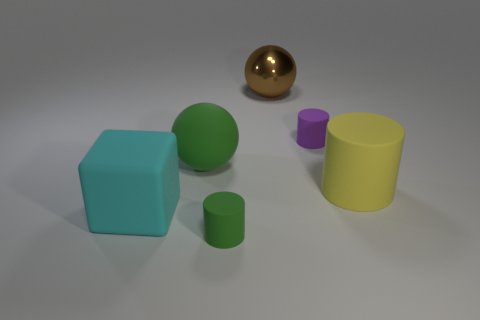What time of day does the lighting in the scene suggest? The lighting in the scene appears neutral, with diffused shadows indicating an overcast sky or indoor lighting rather than a specific time of day. It gives a controlled and even illumination, commonly used in product visualization. 